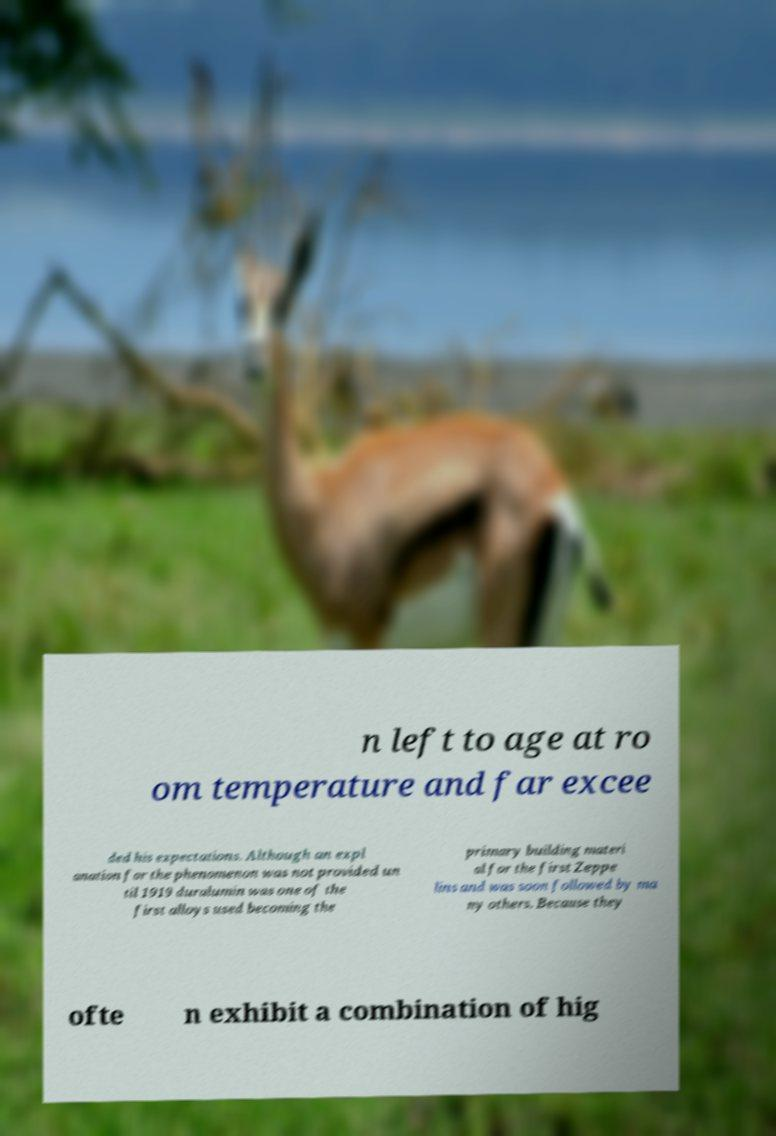Can you read and provide the text displayed in the image?This photo seems to have some interesting text. Can you extract and type it out for me? n left to age at ro om temperature and far excee ded his expectations. Although an expl anation for the phenomenon was not provided un til 1919 duralumin was one of the first alloys used becoming the primary building materi al for the first Zeppe lins and was soon followed by ma ny others. Because they ofte n exhibit a combination of hig 